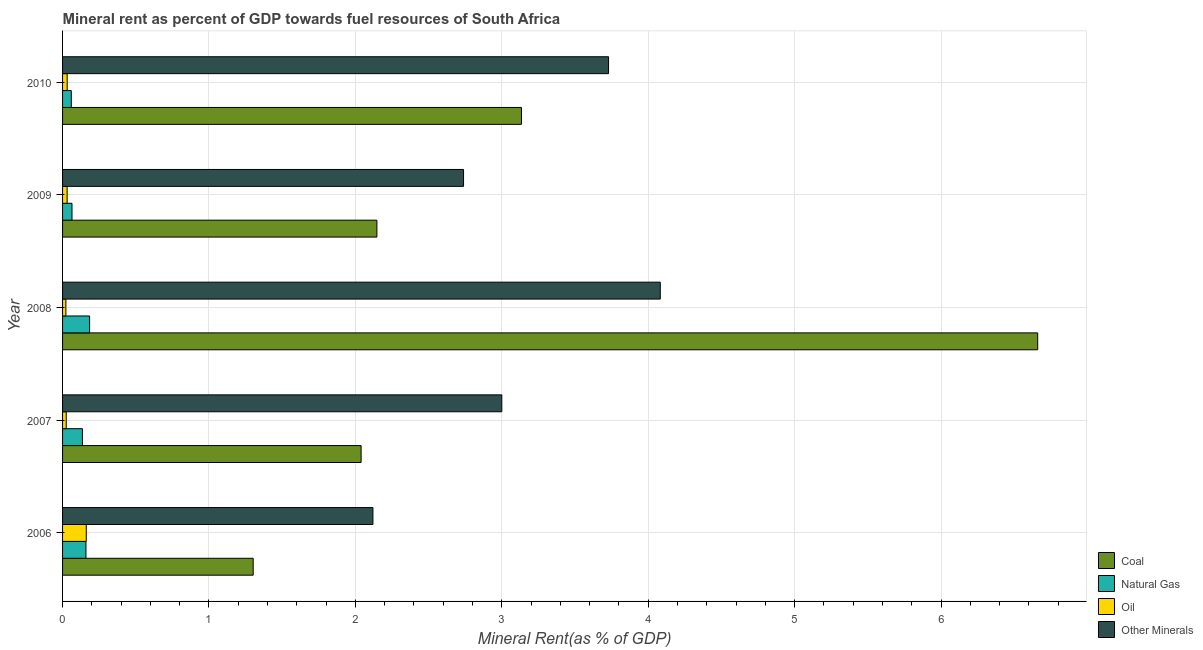Are the number of bars per tick equal to the number of legend labels?
Your answer should be very brief. Yes. How many bars are there on the 4th tick from the top?
Offer a terse response. 4. How many bars are there on the 1st tick from the bottom?
Offer a terse response. 4. What is the label of the 1st group of bars from the top?
Make the answer very short. 2010. In how many cases, is the number of bars for a given year not equal to the number of legend labels?
Your answer should be compact. 0. What is the  rent of other minerals in 2009?
Your response must be concise. 2.74. Across all years, what is the maximum coal rent?
Provide a short and direct response. 6.66. Across all years, what is the minimum oil rent?
Offer a very short reply. 0.02. In which year was the natural gas rent minimum?
Provide a succinct answer. 2010. What is the total oil rent in the graph?
Your answer should be very brief. 0.27. What is the difference between the  rent of other minerals in 2006 and that in 2007?
Your answer should be very brief. -0.88. What is the difference between the coal rent in 2007 and the oil rent in 2006?
Offer a terse response. 1.88. What is the average oil rent per year?
Make the answer very short. 0.05. In the year 2009, what is the difference between the oil rent and natural gas rent?
Keep it short and to the point. -0.03. What is the ratio of the oil rent in 2008 to that in 2009?
Your response must be concise. 0.73. Is the difference between the oil rent in 2008 and 2009 greater than the difference between the  rent of other minerals in 2008 and 2009?
Your response must be concise. No. What is the difference between the highest and the second highest natural gas rent?
Provide a succinct answer. 0.03. What is the difference between the highest and the lowest natural gas rent?
Offer a very short reply. 0.13. In how many years, is the  rent of other minerals greater than the average  rent of other minerals taken over all years?
Provide a short and direct response. 2. Is it the case that in every year, the sum of the  rent of other minerals and oil rent is greater than the sum of coal rent and natural gas rent?
Offer a terse response. No. What does the 1st bar from the top in 2007 represents?
Offer a terse response. Other Minerals. What does the 4th bar from the bottom in 2006 represents?
Provide a succinct answer. Other Minerals. Is it the case that in every year, the sum of the coal rent and natural gas rent is greater than the oil rent?
Your response must be concise. Yes. How many bars are there?
Provide a short and direct response. 20. Are all the bars in the graph horizontal?
Make the answer very short. Yes. What is the difference between two consecutive major ticks on the X-axis?
Ensure brevity in your answer.  1. Does the graph contain any zero values?
Your response must be concise. No. How many legend labels are there?
Offer a terse response. 4. What is the title of the graph?
Provide a succinct answer. Mineral rent as percent of GDP towards fuel resources of South Africa. What is the label or title of the X-axis?
Your answer should be very brief. Mineral Rent(as % of GDP). What is the label or title of the Y-axis?
Offer a very short reply. Year. What is the Mineral Rent(as % of GDP) in Coal in 2006?
Offer a terse response. 1.3. What is the Mineral Rent(as % of GDP) of Natural Gas in 2006?
Provide a short and direct response. 0.16. What is the Mineral Rent(as % of GDP) in Oil in 2006?
Make the answer very short. 0.16. What is the Mineral Rent(as % of GDP) in Other Minerals in 2006?
Your response must be concise. 2.12. What is the Mineral Rent(as % of GDP) in Coal in 2007?
Provide a succinct answer. 2.04. What is the Mineral Rent(as % of GDP) in Natural Gas in 2007?
Offer a terse response. 0.14. What is the Mineral Rent(as % of GDP) of Oil in 2007?
Your answer should be compact. 0.03. What is the Mineral Rent(as % of GDP) in Other Minerals in 2007?
Give a very brief answer. 3. What is the Mineral Rent(as % of GDP) in Coal in 2008?
Provide a short and direct response. 6.66. What is the Mineral Rent(as % of GDP) of Natural Gas in 2008?
Your answer should be very brief. 0.18. What is the Mineral Rent(as % of GDP) of Oil in 2008?
Provide a succinct answer. 0.02. What is the Mineral Rent(as % of GDP) of Other Minerals in 2008?
Offer a terse response. 4.08. What is the Mineral Rent(as % of GDP) in Coal in 2009?
Your answer should be compact. 2.15. What is the Mineral Rent(as % of GDP) of Natural Gas in 2009?
Your response must be concise. 0.06. What is the Mineral Rent(as % of GDP) in Oil in 2009?
Your answer should be very brief. 0.03. What is the Mineral Rent(as % of GDP) of Other Minerals in 2009?
Give a very brief answer. 2.74. What is the Mineral Rent(as % of GDP) of Coal in 2010?
Offer a terse response. 3.13. What is the Mineral Rent(as % of GDP) of Natural Gas in 2010?
Offer a very short reply. 0.06. What is the Mineral Rent(as % of GDP) in Oil in 2010?
Keep it short and to the point. 0.03. What is the Mineral Rent(as % of GDP) in Other Minerals in 2010?
Keep it short and to the point. 3.73. Across all years, what is the maximum Mineral Rent(as % of GDP) in Coal?
Offer a terse response. 6.66. Across all years, what is the maximum Mineral Rent(as % of GDP) of Natural Gas?
Your answer should be compact. 0.18. Across all years, what is the maximum Mineral Rent(as % of GDP) of Oil?
Keep it short and to the point. 0.16. Across all years, what is the maximum Mineral Rent(as % of GDP) of Other Minerals?
Provide a short and direct response. 4.08. Across all years, what is the minimum Mineral Rent(as % of GDP) in Coal?
Your answer should be very brief. 1.3. Across all years, what is the minimum Mineral Rent(as % of GDP) of Natural Gas?
Ensure brevity in your answer.  0.06. Across all years, what is the minimum Mineral Rent(as % of GDP) of Oil?
Your answer should be very brief. 0.02. Across all years, what is the minimum Mineral Rent(as % of GDP) in Other Minerals?
Give a very brief answer. 2.12. What is the total Mineral Rent(as % of GDP) of Coal in the graph?
Provide a succinct answer. 15.28. What is the total Mineral Rent(as % of GDP) of Natural Gas in the graph?
Provide a short and direct response. 0.6. What is the total Mineral Rent(as % of GDP) of Oil in the graph?
Your answer should be very brief. 0.27. What is the total Mineral Rent(as % of GDP) of Other Minerals in the graph?
Give a very brief answer. 15.67. What is the difference between the Mineral Rent(as % of GDP) of Coal in 2006 and that in 2007?
Make the answer very short. -0.74. What is the difference between the Mineral Rent(as % of GDP) of Natural Gas in 2006 and that in 2007?
Offer a very short reply. 0.02. What is the difference between the Mineral Rent(as % of GDP) of Oil in 2006 and that in 2007?
Provide a short and direct response. 0.14. What is the difference between the Mineral Rent(as % of GDP) of Other Minerals in 2006 and that in 2007?
Your answer should be very brief. -0.88. What is the difference between the Mineral Rent(as % of GDP) of Coal in 2006 and that in 2008?
Offer a very short reply. -5.36. What is the difference between the Mineral Rent(as % of GDP) of Natural Gas in 2006 and that in 2008?
Make the answer very short. -0.02. What is the difference between the Mineral Rent(as % of GDP) of Oil in 2006 and that in 2008?
Keep it short and to the point. 0.14. What is the difference between the Mineral Rent(as % of GDP) of Other Minerals in 2006 and that in 2008?
Your answer should be very brief. -1.96. What is the difference between the Mineral Rent(as % of GDP) in Coal in 2006 and that in 2009?
Offer a very short reply. -0.84. What is the difference between the Mineral Rent(as % of GDP) of Natural Gas in 2006 and that in 2009?
Your answer should be compact. 0.1. What is the difference between the Mineral Rent(as % of GDP) of Oil in 2006 and that in 2009?
Your answer should be very brief. 0.13. What is the difference between the Mineral Rent(as % of GDP) in Other Minerals in 2006 and that in 2009?
Give a very brief answer. -0.62. What is the difference between the Mineral Rent(as % of GDP) in Coal in 2006 and that in 2010?
Provide a succinct answer. -1.83. What is the difference between the Mineral Rent(as % of GDP) in Natural Gas in 2006 and that in 2010?
Provide a succinct answer. 0.1. What is the difference between the Mineral Rent(as % of GDP) in Oil in 2006 and that in 2010?
Make the answer very short. 0.13. What is the difference between the Mineral Rent(as % of GDP) in Other Minerals in 2006 and that in 2010?
Your answer should be very brief. -1.61. What is the difference between the Mineral Rent(as % of GDP) of Coal in 2007 and that in 2008?
Your answer should be compact. -4.62. What is the difference between the Mineral Rent(as % of GDP) in Natural Gas in 2007 and that in 2008?
Your answer should be very brief. -0.05. What is the difference between the Mineral Rent(as % of GDP) of Oil in 2007 and that in 2008?
Provide a succinct answer. 0. What is the difference between the Mineral Rent(as % of GDP) in Other Minerals in 2007 and that in 2008?
Your response must be concise. -1.08. What is the difference between the Mineral Rent(as % of GDP) of Coal in 2007 and that in 2009?
Ensure brevity in your answer.  -0.11. What is the difference between the Mineral Rent(as % of GDP) of Natural Gas in 2007 and that in 2009?
Ensure brevity in your answer.  0.07. What is the difference between the Mineral Rent(as % of GDP) of Oil in 2007 and that in 2009?
Make the answer very short. -0.01. What is the difference between the Mineral Rent(as % of GDP) in Other Minerals in 2007 and that in 2009?
Your answer should be very brief. 0.26. What is the difference between the Mineral Rent(as % of GDP) in Coal in 2007 and that in 2010?
Make the answer very short. -1.1. What is the difference between the Mineral Rent(as % of GDP) of Natural Gas in 2007 and that in 2010?
Provide a succinct answer. 0.08. What is the difference between the Mineral Rent(as % of GDP) in Oil in 2007 and that in 2010?
Ensure brevity in your answer.  -0.01. What is the difference between the Mineral Rent(as % of GDP) of Other Minerals in 2007 and that in 2010?
Give a very brief answer. -0.73. What is the difference between the Mineral Rent(as % of GDP) of Coal in 2008 and that in 2009?
Offer a very short reply. 4.51. What is the difference between the Mineral Rent(as % of GDP) in Natural Gas in 2008 and that in 2009?
Ensure brevity in your answer.  0.12. What is the difference between the Mineral Rent(as % of GDP) of Oil in 2008 and that in 2009?
Give a very brief answer. -0.01. What is the difference between the Mineral Rent(as % of GDP) of Other Minerals in 2008 and that in 2009?
Provide a succinct answer. 1.34. What is the difference between the Mineral Rent(as % of GDP) of Coal in 2008 and that in 2010?
Offer a terse response. 3.53. What is the difference between the Mineral Rent(as % of GDP) in Natural Gas in 2008 and that in 2010?
Offer a terse response. 0.12. What is the difference between the Mineral Rent(as % of GDP) in Oil in 2008 and that in 2010?
Provide a succinct answer. -0.01. What is the difference between the Mineral Rent(as % of GDP) of Other Minerals in 2008 and that in 2010?
Keep it short and to the point. 0.35. What is the difference between the Mineral Rent(as % of GDP) in Coal in 2009 and that in 2010?
Offer a terse response. -0.99. What is the difference between the Mineral Rent(as % of GDP) of Natural Gas in 2009 and that in 2010?
Ensure brevity in your answer.  0. What is the difference between the Mineral Rent(as % of GDP) of Oil in 2009 and that in 2010?
Make the answer very short. -0. What is the difference between the Mineral Rent(as % of GDP) of Other Minerals in 2009 and that in 2010?
Offer a very short reply. -0.99. What is the difference between the Mineral Rent(as % of GDP) of Coal in 2006 and the Mineral Rent(as % of GDP) of Natural Gas in 2007?
Give a very brief answer. 1.17. What is the difference between the Mineral Rent(as % of GDP) in Coal in 2006 and the Mineral Rent(as % of GDP) in Oil in 2007?
Your answer should be very brief. 1.28. What is the difference between the Mineral Rent(as % of GDP) of Coal in 2006 and the Mineral Rent(as % of GDP) of Other Minerals in 2007?
Make the answer very short. -1.7. What is the difference between the Mineral Rent(as % of GDP) of Natural Gas in 2006 and the Mineral Rent(as % of GDP) of Oil in 2007?
Your answer should be very brief. 0.13. What is the difference between the Mineral Rent(as % of GDP) in Natural Gas in 2006 and the Mineral Rent(as % of GDP) in Other Minerals in 2007?
Provide a short and direct response. -2.84. What is the difference between the Mineral Rent(as % of GDP) of Oil in 2006 and the Mineral Rent(as % of GDP) of Other Minerals in 2007?
Ensure brevity in your answer.  -2.84. What is the difference between the Mineral Rent(as % of GDP) in Coal in 2006 and the Mineral Rent(as % of GDP) in Natural Gas in 2008?
Offer a very short reply. 1.12. What is the difference between the Mineral Rent(as % of GDP) in Coal in 2006 and the Mineral Rent(as % of GDP) in Oil in 2008?
Offer a very short reply. 1.28. What is the difference between the Mineral Rent(as % of GDP) in Coal in 2006 and the Mineral Rent(as % of GDP) in Other Minerals in 2008?
Provide a short and direct response. -2.78. What is the difference between the Mineral Rent(as % of GDP) in Natural Gas in 2006 and the Mineral Rent(as % of GDP) in Oil in 2008?
Provide a succinct answer. 0.14. What is the difference between the Mineral Rent(as % of GDP) in Natural Gas in 2006 and the Mineral Rent(as % of GDP) in Other Minerals in 2008?
Provide a short and direct response. -3.92. What is the difference between the Mineral Rent(as % of GDP) of Oil in 2006 and the Mineral Rent(as % of GDP) of Other Minerals in 2008?
Offer a very short reply. -3.92. What is the difference between the Mineral Rent(as % of GDP) in Coal in 2006 and the Mineral Rent(as % of GDP) in Natural Gas in 2009?
Offer a very short reply. 1.24. What is the difference between the Mineral Rent(as % of GDP) of Coal in 2006 and the Mineral Rent(as % of GDP) of Oil in 2009?
Offer a terse response. 1.27. What is the difference between the Mineral Rent(as % of GDP) in Coal in 2006 and the Mineral Rent(as % of GDP) in Other Minerals in 2009?
Your answer should be very brief. -1.44. What is the difference between the Mineral Rent(as % of GDP) in Natural Gas in 2006 and the Mineral Rent(as % of GDP) in Oil in 2009?
Offer a terse response. 0.13. What is the difference between the Mineral Rent(as % of GDP) in Natural Gas in 2006 and the Mineral Rent(as % of GDP) in Other Minerals in 2009?
Your answer should be very brief. -2.58. What is the difference between the Mineral Rent(as % of GDP) of Oil in 2006 and the Mineral Rent(as % of GDP) of Other Minerals in 2009?
Offer a terse response. -2.58. What is the difference between the Mineral Rent(as % of GDP) in Coal in 2006 and the Mineral Rent(as % of GDP) in Natural Gas in 2010?
Make the answer very short. 1.24. What is the difference between the Mineral Rent(as % of GDP) in Coal in 2006 and the Mineral Rent(as % of GDP) in Oil in 2010?
Your answer should be compact. 1.27. What is the difference between the Mineral Rent(as % of GDP) of Coal in 2006 and the Mineral Rent(as % of GDP) of Other Minerals in 2010?
Give a very brief answer. -2.43. What is the difference between the Mineral Rent(as % of GDP) in Natural Gas in 2006 and the Mineral Rent(as % of GDP) in Oil in 2010?
Keep it short and to the point. 0.13. What is the difference between the Mineral Rent(as % of GDP) in Natural Gas in 2006 and the Mineral Rent(as % of GDP) in Other Minerals in 2010?
Keep it short and to the point. -3.57. What is the difference between the Mineral Rent(as % of GDP) in Oil in 2006 and the Mineral Rent(as % of GDP) in Other Minerals in 2010?
Provide a short and direct response. -3.57. What is the difference between the Mineral Rent(as % of GDP) of Coal in 2007 and the Mineral Rent(as % of GDP) of Natural Gas in 2008?
Make the answer very short. 1.85. What is the difference between the Mineral Rent(as % of GDP) of Coal in 2007 and the Mineral Rent(as % of GDP) of Oil in 2008?
Keep it short and to the point. 2.02. What is the difference between the Mineral Rent(as % of GDP) in Coal in 2007 and the Mineral Rent(as % of GDP) in Other Minerals in 2008?
Ensure brevity in your answer.  -2.04. What is the difference between the Mineral Rent(as % of GDP) in Natural Gas in 2007 and the Mineral Rent(as % of GDP) in Oil in 2008?
Your answer should be very brief. 0.11. What is the difference between the Mineral Rent(as % of GDP) in Natural Gas in 2007 and the Mineral Rent(as % of GDP) in Other Minerals in 2008?
Your answer should be compact. -3.95. What is the difference between the Mineral Rent(as % of GDP) in Oil in 2007 and the Mineral Rent(as % of GDP) in Other Minerals in 2008?
Offer a terse response. -4.06. What is the difference between the Mineral Rent(as % of GDP) in Coal in 2007 and the Mineral Rent(as % of GDP) in Natural Gas in 2009?
Offer a very short reply. 1.97. What is the difference between the Mineral Rent(as % of GDP) of Coal in 2007 and the Mineral Rent(as % of GDP) of Oil in 2009?
Keep it short and to the point. 2.01. What is the difference between the Mineral Rent(as % of GDP) of Coal in 2007 and the Mineral Rent(as % of GDP) of Other Minerals in 2009?
Make the answer very short. -0.7. What is the difference between the Mineral Rent(as % of GDP) of Natural Gas in 2007 and the Mineral Rent(as % of GDP) of Oil in 2009?
Your response must be concise. 0.1. What is the difference between the Mineral Rent(as % of GDP) in Natural Gas in 2007 and the Mineral Rent(as % of GDP) in Other Minerals in 2009?
Offer a very short reply. -2.6. What is the difference between the Mineral Rent(as % of GDP) of Oil in 2007 and the Mineral Rent(as % of GDP) of Other Minerals in 2009?
Your answer should be very brief. -2.71. What is the difference between the Mineral Rent(as % of GDP) of Coal in 2007 and the Mineral Rent(as % of GDP) of Natural Gas in 2010?
Keep it short and to the point. 1.98. What is the difference between the Mineral Rent(as % of GDP) of Coal in 2007 and the Mineral Rent(as % of GDP) of Oil in 2010?
Keep it short and to the point. 2.01. What is the difference between the Mineral Rent(as % of GDP) in Coal in 2007 and the Mineral Rent(as % of GDP) in Other Minerals in 2010?
Provide a short and direct response. -1.69. What is the difference between the Mineral Rent(as % of GDP) in Natural Gas in 2007 and the Mineral Rent(as % of GDP) in Oil in 2010?
Your response must be concise. 0.1. What is the difference between the Mineral Rent(as % of GDP) in Natural Gas in 2007 and the Mineral Rent(as % of GDP) in Other Minerals in 2010?
Your answer should be very brief. -3.59. What is the difference between the Mineral Rent(as % of GDP) in Oil in 2007 and the Mineral Rent(as % of GDP) in Other Minerals in 2010?
Your answer should be very brief. -3.7. What is the difference between the Mineral Rent(as % of GDP) of Coal in 2008 and the Mineral Rent(as % of GDP) of Natural Gas in 2009?
Make the answer very short. 6.6. What is the difference between the Mineral Rent(as % of GDP) in Coal in 2008 and the Mineral Rent(as % of GDP) in Oil in 2009?
Ensure brevity in your answer.  6.63. What is the difference between the Mineral Rent(as % of GDP) of Coal in 2008 and the Mineral Rent(as % of GDP) of Other Minerals in 2009?
Your answer should be very brief. 3.92. What is the difference between the Mineral Rent(as % of GDP) of Natural Gas in 2008 and the Mineral Rent(as % of GDP) of Oil in 2009?
Give a very brief answer. 0.15. What is the difference between the Mineral Rent(as % of GDP) in Natural Gas in 2008 and the Mineral Rent(as % of GDP) in Other Minerals in 2009?
Your answer should be very brief. -2.55. What is the difference between the Mineral Rent(as % of GDP) in Oil in 2008 and the Mineral Rent(as % of GDP) in Other Minerals in 2009?
Provide a short and direct response. -2.72. What is the difference between the Mineral Rent(as % of GDP) in Coal in 2008 and the Mineral Rent(as % of GDP) in Natural Gas in 2010?
Make the answer very short. 6.6. What is the difference between the Mineral Rent(as % of GDP) in Coal in 2008 and the Mineral Rent(as % of GDP) in Oil in 2010?
Your response must be concise. 6.63. What is the difference between the Mineral Rent(as % of GDP) of Coal in 2008 and the Mineral Rent(as % of GDP) of Other Minerals in 2010?
Your response must be concise. 2.93. What is the difference between the Mineral Rent(as % of GDP) of Natural Gas in 2008 and the Mineral Rent(as % of GDP) of Oil in 2010?
Provide a succinct answer. 0.15. What is the difference between the Mineral Rent(as % of GDP) of Natural Gas in 2008 and the Mineral Rent(as % of GDP) of Other Minerals in 2010?
Your response must be concise. -3.54. What is the difference between the Mineral Rent(as % of GDP) in Oil in 2008 and the Mineral Rent(as % of GDP) in Other Minerals in 2010?
Ensure brevity in your answer.  -3.71. What is the difference between the Mineral Rent(as % of GDP) of Coal in 2009 and the Mineral Rent(as % of GDP) of Natural Gas in 2010?
Provide a succinct answer. 2.09. What is the difference between the Mineral Rent(as % of GDP) in Coal in 2009 and the Mineral Rent(as % of GDP) in Oil in 2010?
Provide a short and direct response. 2.12. What is the difference between the Mineral Rent(as % of GDP) in Coal in 2009 and the Mineral Rent(as % of GDP) in Other Minerals in 2010?
Ensure brevity in your answer.  -1.58. What is the difference between the Mineral Rent(as % of GDP) in Natural Gas in 2009 and the Mineral Rent(as % of GDP) in Oil in 2010?
Give a very brief answer. 0.03. What is the difference between the Mineral Rent(as % of GDP) of Natural Gas in 2009 and the Mineral Rent(as % of GDP) of Other Minerals in 2010?
Offer a terse response. -3.66. What is the difference between the Mineral Rent(as % of GDP) in Oil in 2009 and the Mineral Rent(as % of GDP) in Other Minerals in 2010?
Make the answer very short. -3.7. What is the average Mineral Rent(as % of GDP) in Coal per year?
Offer a very short reply. 3.06. What is the average Mineral Rent(as % of GDP) in Natural Gas per year?
Give a very brief answer. 0.12. What is the average Mineral Rent(as % of GDP) in Oil per year?
Provide a succinct answer. 0.05. What is the average Mineral Rent(as % of GDP) of Other Minerals per year?
Your answer should be very brief. 3.13. In the year 2006, what is the difference between the Mineral Rent(as % of GDP) in Coal and Mineral Rent(as % of GDP) in Natural Gas?
Your answer should be compact. 1.14. In the year 2006, what is the difference between the Mineral Rent(as % of GDP) in Coal and Mineral Rent(as % of GDP) in Oil?
Ensure brevity in your answer.  1.14. In the year 2006, what is the difference between the Mineral Rent(as % of GDP) of Coal and Mineral Rent(as % of GDP) of Other Minerals?
Your response must be concise. -0.82. In the year 2006, what is the difference between the Mineral Rent(as % of GDP) in Natural Gas and Mineral Rent(as % of GDP) in Oil?
Give a very brief answer. -0. In the year 2006, what is the difference between the Mineral Rent(as % of GDP) in Natural Gas and Mineral Rent(as % of GDP) in Other Minerals?
Provide a succinct answer. -1.96. In the year 2006, what is the difference between the Mineral Rent(as % of GDP) of Oil and Mineral Rent(as % of GDP) of Other Minerals?
Your answer should be compact. -1.96. In the year 2007, what is the difference between the Mineral Rent(as % of GDP) of Coal and Mineral Rent(as % of GDP) of Natural Gas?
Provide a short and direct response. 1.9. In the year 2007, what is the difference between the Mineral Rent(as % of GDP) of Coal and Mineral Rent(as % of GDP) of Oil?
Make the answer very short. 2.01. In the year 2007, what is the difference between the Mineral Rent(as % of GDP) of Coal and Mineral Rent(as % of GDP) of Other Minerals?
Provide a short and direct response. -0.96. In the year 2007, what is the difference between the Mineral Rent(as % of GDP) in Natural Gas and Mineral Rent(as % of GDP) in Oil?
Provide a succinct answer. 0.11. In the year 2007, what is the difference between the Mineral Rent(as % of GDP) of Natural Gas and Mineral Rent(as % of GDP) of Other Minerals?
Make the answer very short. -2.86. In the year 2007, what is the difference between the Mineral Rent(as % of GDP) in Oil and Mineral Rent(as % of GDP) in Other Minerals?
Ensure brevity in your answer.  -2.98. In the year 2008, what is the difference between the Mineral Rent(as % of GDP) in Coal and Mineral Rent(as % of GDP) in Natural Gas?
Offer a terse response. 6.48. In the year 2008, what is the difference between the Mineral Rent(as % of GDP) in Coal and Mineral Rent(as % of GDP) in Oil?
Your answer should be very brief. 6.64. In the year 2008, what is the difference between the Mineral Rent(as % of GDP) of Coal and Mineral Rent(as % of GDP) of Other Minerals?
Offer a very short reply. 2.58. In the year 2008, what is the difference between the Mineral Rent(as % of GDP) of Natural Gas and Mineral Rent(as % of GDP) of Oil?
Ensure brevity in your answer.  0.16. In the year 2008, what is the difference between the Mineral Rent(as % of GDP) of Natural Gas and Mineral Rent(as % of GDP) of Other Minerals?
Provide a succinct answer. -3.9. In the year 2008, what is the difference between the Mineral Rent(as % of GDP) in Oil and Mineral Rent(as % of GDP) in Other Minerals?
Your answer should be compact. -4.06. In the year 2009, what is the difference between the Mineral Rent(as % of GDP) in Coal and Mineral Rent(as % of GDP) in Natural Gas?
Your answer should be very brief. 2.08. In the year 2009, what is the difference between the Mineral Rent(as % of GDP) in Coal and Mineral Rent(as % of GDP) in Oil?
Offer a terse response. 2.12. In the year 2009, what is the difference between the Mineral Rent(as % of GDP) in Coal and Mineral Rent(as % of GDP) in Other Minerals?
Provide a succinct answer. -0.59. In the year 2009, what is the difference between the Mineral Rent(as % of GDP) in Natural Gas and Mineral Rent(as % of GDP) in Oil?
Provide a short and direct response. 0.03. In the year 2009, what is the difference between the Mineral Rent(as % of GDP) of Natural Gas and Mineral Rent(as % of GDP) of Other Minerals?
Ensure brevity in your answer.  -2.67. In the year 2009, what is the difference between the Mineral Rent(as % of GDP) in Oil and Mineral Rent(as % of GDP) in Other Minerals?
Provide a short and direct response. -2.71. In the year 2010, what is the difference between the Mineral Rent(as % of GDP) of Coal and Mineral Rent(as % of GDP) of Natural Gas?
Offer a very short reply. 3.07. In the year 2010, what is the difference between the Mineral Rent(as % of GDP) of Coal and Mineral Rent(as % of GDP) of Oil?
Offer a very short reply. 3.1. In the year 2010, what is the difference between the Mineral Rent(as % of GDP) in Coal and Mineral Rent(as % of GDP) in Other Minerals?
Give a very brief answer. -0.59. In the year 2010, what is the difference between the Mineral Rent(as % of GDP) in Natural Gas and Mineral Rent(as % of GDP) in Oil?
Offer a very short reply. 0.03. In the year 2010, what is the difference between the Mineral Rent(as % of GDP) of Natural Gas and Mineral Rent(as % of GDP) of Other Minerals?
Offer a terse response. -3.67. In the year 2010, what is the difference between the Mineral Rent(as % of GDP) of Oil and Mineral Rent(as % of GDP) of Other Minerals?
Give a very brief answer. -3.7. What is the ratio of the Mineral Rent(as % of GDP) of Coal in 2006 to that in 2007?
Offer a terse response. 0.64. What is the ratio of the Mineral Rent(as % of GDP) of Natural Gas in 2006 to that in 2007?
Provide a short and direct response. 1.18. What is the ratio of the Mineral Rent(as % of GDP) of Oil in 2006 to that in 2007?
Offer a terse response. 6.47. What is the ratio of the Mineral Rent(as % of GDP) in Other Minerals in 2006 to that in 2007?
Offer a terse response. 0.71. What is the ratio of the Mineral Rent(as % of GDP) in Coal in 2006 to that in 2008?
Your response must be concise. 0.2. What is the ratio of the Mineral Rent(as % of GDP) of Natural Gas in 2006 to that in 2008?
Give a very brief answer. 0.86. What is the ratio of the Mineral Rent(as % of GDP) in Oil in 2006 to that in 2008?
Make the answer very short. 7.16. What is the ratio of the Mineral Rent(as % of GDP) in Other Minerals in 2006 to that in 2008?
Keep it short and to the point. 0.52. What is the ratio of the Mineral Rent(as % of GDP) of Coal in 2006 to that in 2009?
Offer a very short reply. 0.61. What is the ratio of the Mineral Rent(as % of GDP) in Natural Gas in 2006 to that in 2009?
Your answer should be very brief. 2.48. What is the ratio of the Mineral Rent(as % of GDP) in Oil in 2006 to that in 2009?
Your answer should be very brief. 5.2. What is the ratio of the Mineral Rent(as % of GDP) of Other Minerals in 2006 to that in 2009?
Your answer should be compact. 0.77. What is the ratio of the Mineral Rent(as % of GDP) in Coal in 2006 to that in 2010?
Your response must be concise. 0.42. What is the ratio of the Mineral Rent(as % of GDP) of Natural Gas in 2006 to that in 2010?
Keep it short and to the point. 2.68. What is the ratio of the Mineral Rent(as % of GDP) of Oil in 2006 to that in 2010?
Your answer should be compact. 5.14. What is the ratio of the Mineral Rent(as % of GDP) in Other Minerals in 2006 to that in 2010?
Make the answer very short. 0.57. What is the ratio of the Mineral Rent(as % of GDP) of Coal in 2007 to that in 2008?
Give a very brief answer. 0.31. What is the ratio of the Mineral Rent(as % of GDP) in Natural Gas in 2007 to that in 2008?
Offer a very short reply. 0.73. What is the ratio of the Mineral Rent(as % of GDP) of Oil in 2007 to that in 2008?
Offer a very short reply. 1.11. What is the ratio of the Mineral Rent(as % of GDP) of Other Minerals in 2007 to that in 2008?
Provide a short and direct response. 0.73. What is the ratio of the Mineral Rent(as % of GDP) of Coal in 2007 to that in 2009?
Ensure brevity in your answer.  0.95. What is the ratio of the Mineral Rent(as % of GDP) of Natural Gas in 2007 to that in 2009?
Offer a very short reply. 2.1. What is the ratio of the Mineral Rent(as % of GDP) of Oil in 2007 to that in 2009?
Provide a short and direct response. 0.8. What is the ratio of the Mineral Rent(as % of GDP) of Other Minerals in 2007 to that in 2009?
Provide a short and direct response. 1.1. What is the ratio of the Mineral Rent(as % of GDP) of Coal in 2007 to that in 2010?
Ensure brevity in your answer.  0.65. What is the ratio of the Mineral Rent(as % of GDP) of Natural Gas in 2007 to that in 2010?
Give a very brief answer. 2.27. What is the ratio of the Mineral Rent(as % of GDP) of Oil in 2007 to that in 2010?
Provide a short and direct response. 0.79. What is the ratio of the Mineral Rent(as % of GDP) in Other Minerals in 2007 to that in 2010?
Your response must be concise. 0.8. What is the ratio of the Mineral Rent(as % of GDP) of Coal in 2008 to that in 2009?
Your response must be concise. 3.1. What is the ratio of the Mineral Rent(as % of GDP) in Natural Gas in 2008 to that in 2009?
Make the answer very short. 2.87. What is the ratio of the Mineral Rent(as % of GDP) of Oil in 2008 to that in 2009?
Your answer should be very brief. 0.73. What is the ratio of the Mineral Rent(as % of GDP) of Other Minerals in 2008 to that in 2009?
Ensure brevity in your answer.  1.49. What is the ratio of the Mineral Rent(as % of GDP) of Coal in 2008 to that in 2010?
Your response must be concise. 2.12. What is the ratio of the Mineral Rent(as % of GDP) in Natural Gas in 2008 to that in 2010?
Make the answer very short. 3.1. What is the ratio of the Mineral Rent(as % of GDP) of Oil in 2008 to that in 2010?
Provide a short and direct response. 0.72. What is the ratio of the Mineral Rent(as % of GDP) of Other Minerals in 2008 to that in 2010?
Keep it short and to the point. 1.09. What is the ratio of the Mineral Rent(as % of GDP) of Coal in 2009 to that in 2010?
Your answer should be very brief. 0.69. What is the ratio of the Mineral Rent(as % of GDP) in Natural Gas in 2009 to that in 2010?
Give a very brief answer. 1.08. What is the ratio of the Mineral Rent(as % of GDP) of Other Minerals in 2009 to that in 2010?
Your response must be concise. 0.73. What is the difference between the highest and the second highest Mineral Rent(as % of GDP) in Coal?
Offer a terse response. 3.53. What is the difference between the highest and the second highest Mineral Rent(as % of GDP) of Natural Gas?
Provide a short and direct response. 0.02. What is the difference between the highest and the second highest Mineral Rent(as % of GDP) in Oil?
Give a very brief answer. 0.13. What is the difference between the highest and the second highest Mineral Rent(as % of GDP) in Other Minerals?
Keep it short and to the point. 0.35. What is the difference between the highest and the lowest Mineral Rent(as % of GDP) of Coal?
Give a very brief answer. 5.36. What is the difference between the highest and the lowest Mineral Rent(as % of GDP) in Oil?
Your answer should be very brief. 0.14. What is the difference between the highest and the lowest Mineral Rent(as % of GDP) in Other Minerals?
Give a very brief answer. 1.96. 